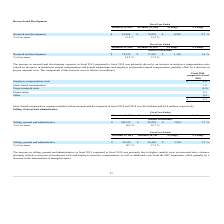According to Formfactor's financial document, What led to increase in research and development expenses in fiscal 2019 compared to fiscal 2018? The increase in research and development expenses in fiscal 2019 compared to fiscal 2018 was primarily driven by an increase in employee compensation costs. The document states: "The increase in research and development expenses in fiscal 2019 compared to fiscal 2018 was primarily driven by an increase in employee compensation ..." Also, can you calculate: What is the average Research and development for the Fiscal Year Ended December 28, 2019 to December 29, 2018?   To answer this question, I need to perform calculations using the financial data. The calculation is: (81,499+74,976) / 2, which equals 78237.5 (in thousands). This is based on the information: "Research and development $ 81,499 $ 74,976 $ 6,523 8.7 % Research and development $ 81,499 $ 74,976 $ 6,523 8.7 %..." The key data points involved are: 74,976, 81,499. Also, can you calculate: What is the average Research and development for the Fiscal Year Ended December 29, 2018 to December 30, 2017? To answer this question, I need to perform calculations using the financial data. The calculation is: (74,976+73,807) / 2, which equals 74391.5 (in thousands). This is based on the information: "Research and development $ 81,499 $ 74,976 $ 6,523 8.7 % Research and development $ 74,976 $ 73,807 $ 1,169 1.6 %..." The key data points involved are: 73,807, 74,976. Additionally, In which year was Research and development less than 80,000 thousands? According to the financial document, 2018. The relevant text states: "December 28, 2019 December 29, 2018 $ Change % Change..." Also, What was the % of revenues in 2019 and 2018? The document shows two values: 13.8 % and 14.2 %. From the document: "% of revenues 13.8 % 14.2 % % of revenues 13.8 % 14.2 %..." Also, What was the change in Research and development from 2018 to 2019? According to the financial document, $6,523 (in thousands). The relevant text states: "Research and development $ 81,499 $ 74,976 $ 6,523 8.7 %..." 